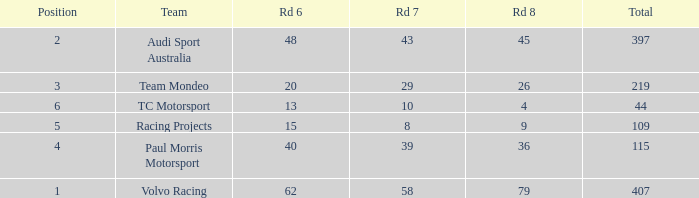What is the average value for Rd 8 in a position less than 2 for Audi Sport Australia? None. I'm looking to parse the entire table for insights. Could you assist me with that? {'header': ['Position', 'Team', 'Rd 6', 'Rd 7', 'Rd 8', 'Total'], 'rows': [['2', 'Audi Sport Australia', '48', '43', '45', '397'], ['3', 'Team Mondeo', '20', '29', '26', '219'], ['6', 'TC Motorsport', '13', '10', '4', '44'], ['5', 'Racing Projects', '15', '8', '9', '109'], ['4', 'Paul Morris Motorsport', '40', '39', '36', '115'], ['1', 'Volvo Racing', '62', '58', '79', '407']]} 